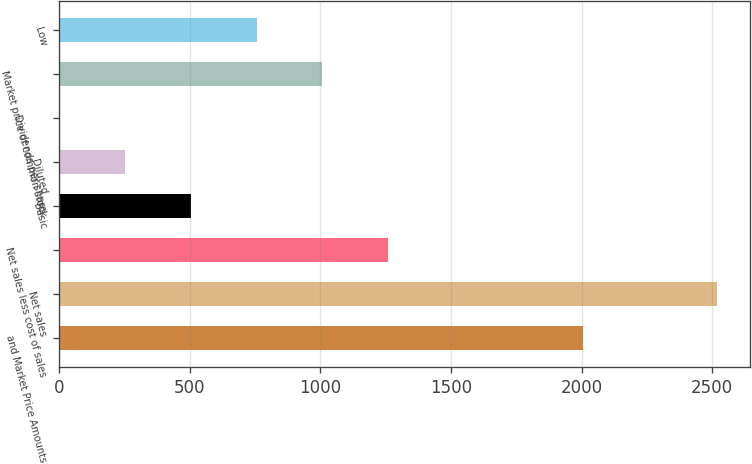Convert chart to OTSL. <chart><loc_0><loc_0><loc_500><loc_500><bar_chart><fcel>and Market Price Amounts<fcel>Net sales<fcel>Net sales less cost of sales<fcel>Basic<fcel>Diluted<fcel>Dividends per share<fcel>Market price of common stock<fcel>Low<nl><fcel>2004<fcel>2518<fcel>1259.13<fcel>503.82<fcel>252.05<fcel>0.28<fcel>1007.36<fcel>755.59<nl></chart> 